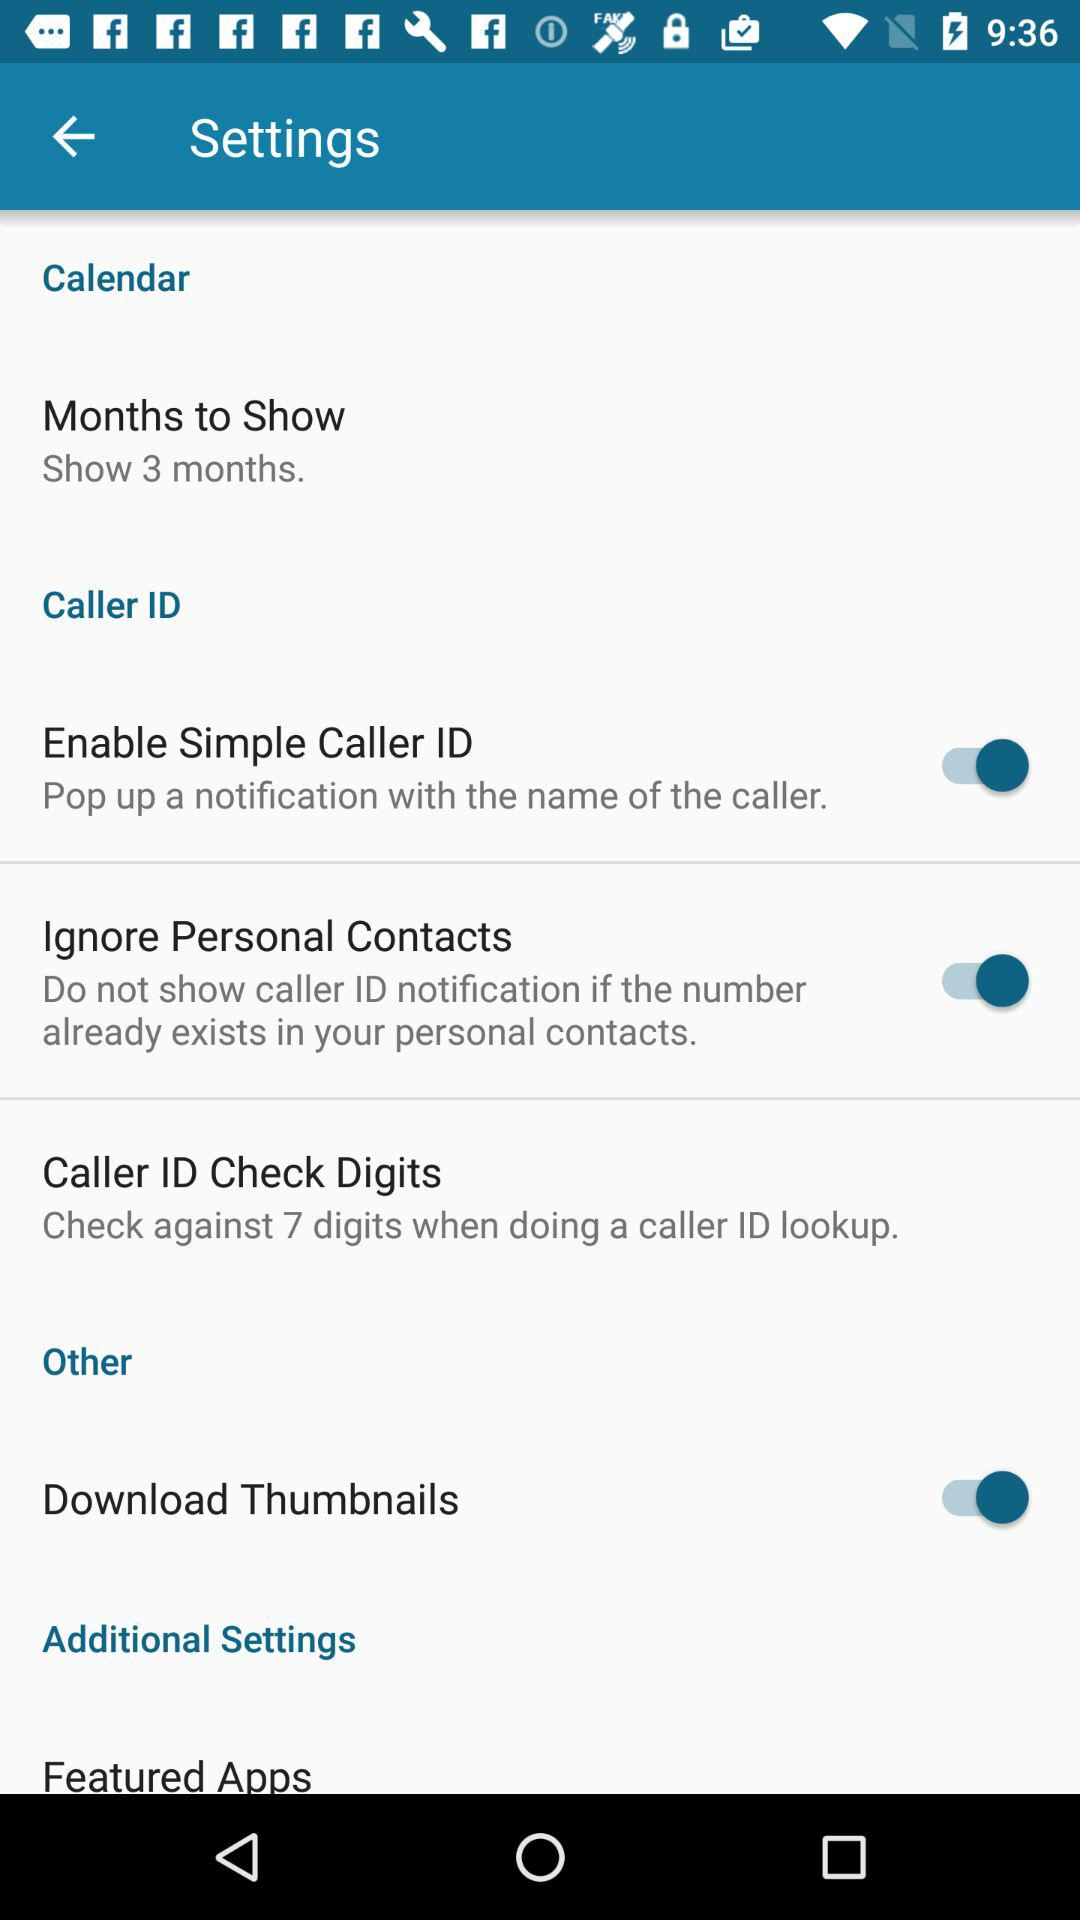How many months will the calendar show? The calendar will show three months. 